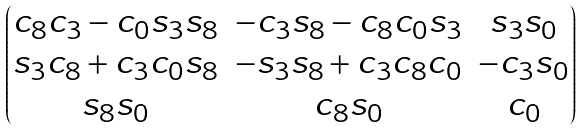<formula> <loc_0><loc_0><loc_500><loc_500>\begin{pmatrix} c _ { 8 } c _ { 3 } - c _ { 0 } s _ { 3 } s _ { 8 } & - c _ { 3 } s _ { 8 } - c _ { 8 } c _ { 0 } s _ { 3 } & s _ { 3 } s _ { 0 } \\ s _ { 3 } c _ { 8 } + c _ { 3 } c _ { 0 } s _ { 8 } & - s _ { 3 } s _ { 8 } + c _ { 3 } c _ { 8 } c _ { 0 } & - c _ { 3 } s _ { 0 } \\ s _ { 8 } s _ { 0 } & c _ { 8 } s _ { 0 } & c _ { 0 } \end{pmatrix}</formula> 